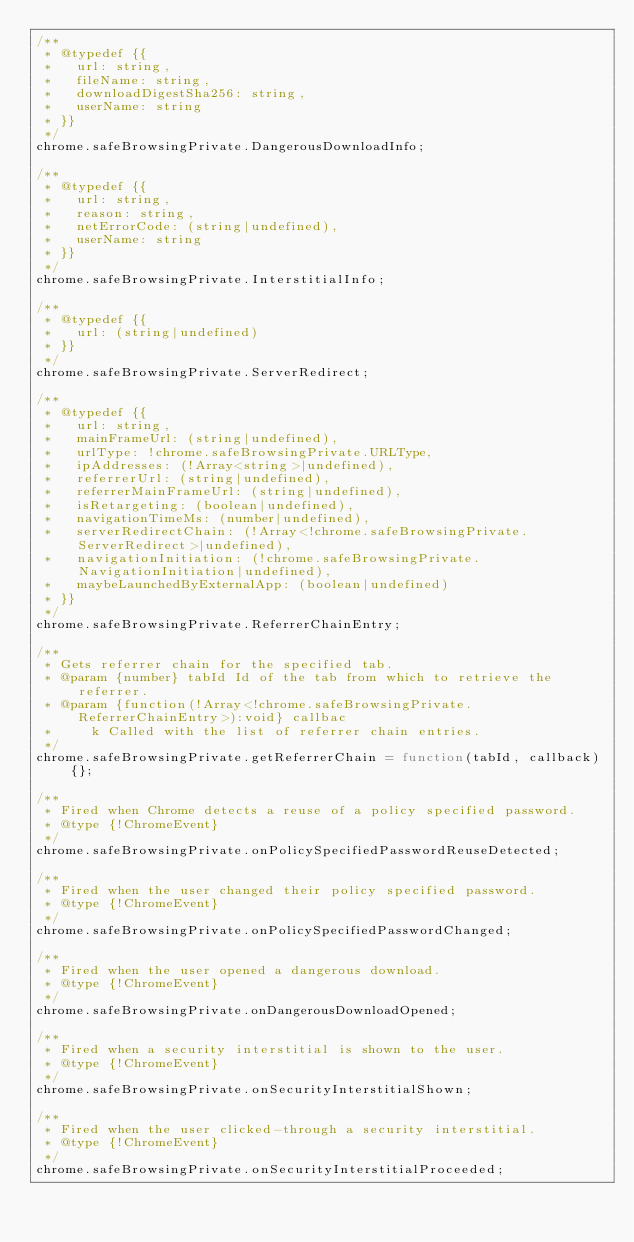Convert code to text. <code><loc_0><loc_0><loc_500><loc_500><_JavaScript_>/**
 * @typedef {{
 *   url: string,
 *   fileName: string,
 *   downloadDigestSha256: string,
 *   userName: string
 * }}
 */
chrome.safeBrowsingPrivate.DangerousDownloadInfo;

/**
 * @typedef {{
 *   url: string,
 *   reason: string,
 *   netErrorCode: (string|undefined),
 *   userName: string
 * }}
 */
chrome.safeBrowsingPrivate.InterstitialInfo;

/**
 * @typedef {{
 *   url: (string|undefined)
 * }}
 */
chrome.safeBrowsingPrivate.ServerRedirect;

/**
 * @typedef {{
 *   url: string,
 *   mainFrameUrl: (string|undefined),
 *   urlType: !chrome.safeBrowsingPrivate.URLType,
 *   ipAddresses: (!Array<string>|undefined),
 *   referrerUrl: (string|undefined),
 *   referrerMainFrameUrl: (string|undefined),
 *   isRetargeting: (boolean|undefined),
 *   navigationTimeMs: (number|undefined),
 *   serverRedirectChain: (!Array<!chrome.safeBrowsingPrivate.ServerRedirect>|undefined),
 *   navigationInitiation: (!chrome.safeBrowsingPrivate.NavigationInitiation|undefined),
 *   maybeLaunchedByExternalApp: (boolean|undefined)
 * }}
 */
chrome.safeBrowsingPrivate.ReferrerChainEntry;

/**
 * Gets referrer chain for the specified tab.
 * @param {number} tabId Id of the tab from which to retrieve the referrer.
 * @param {function(!Array<!chrome.safeBrowsingPrivate.ReferrerChainEntry>):void} callbac
 *     k Called with the list of referrer chain entries.
 */
chrome.safeBrowsingPrivate.getReferrerChain = function(tabId, callback) {};

/**
 * Fired when Chrome detects a reuse of a policy specified password.
 * @type {!ChromeEvent}
 */
chrome.safeBrowsingPrivate.onPolicySpecifiedPasswordReuseDetected;

/**
 * Fired when the user changed their policy specified password.
 * @type {!ChromeEvent}
 */
chrome.safeBrowsingPrivate.onPolicySpecifiedPasswordChanged;

/**
 * Fired when the user opened a dangerous download.
 * @type {!ChromeEvent}
 */
chrome.safeBrowsingPrivate.onDangerousDownloadOpened;

/**
 * Fired when a security interstitial is shown to the user.
 * @type {!ChromeEvent}
 */
chrome.safeBrowsingPrivate.onSecurityInterstitialShown;

/**
 * Fired when the user clicked-through a security interstitial.
 * @type {!ChromeEvent}
 */
chrome.safeBrowsingPrivate.onSecurityInterstitialProceeded;
</code> 